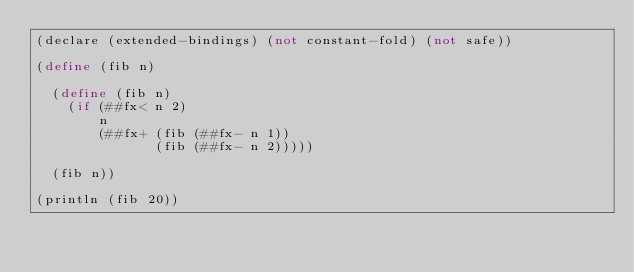Convert code to text. <code><loc_0><loc_0><loc_500><loc_500><_Scheme_>(declare (extended-bindings) (not constant-fold) (not safe))

(define (fib n)

  (define (fib n)
    (if (##fx< n 2)
        n
        (##fx+ (fib (##fx- n 1))
               (fib (##fx- n 2)))))

  (fib n))

(println (fib 20))
</code> 